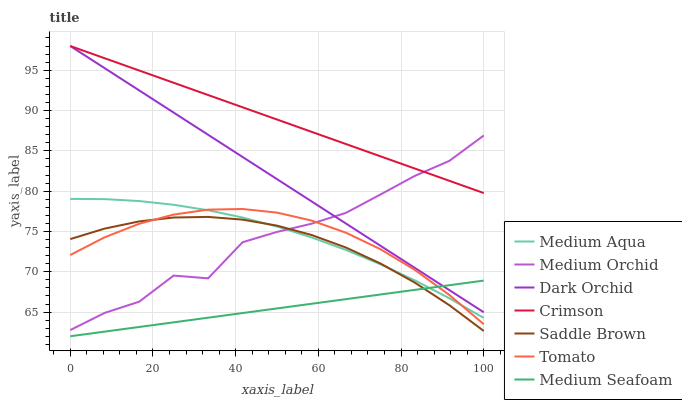Does Medium Seafoam have the minimum area under the curve?
Answer yes or no. Yes. Does Crimson have the maximum area under the curve?
Answer yes or no. Yes. Does Medium Orchid have the minimum area under the curve?
Answer yes or no. No. Does Medium Orchid have the maximum area under the curve?
Answer yes or no. No. Is Medium Seafoam the smoothest?
Answer yes or no. Yes. Is Medium Orchid the roughest?
Answer yes or no. Yes. Is Dark Orchid the smoothest?
Answer yes or no. No. Is Dark Orchid the roughest?
Answer yes or no. No. Does Medium Seafoam have the lowest value?
Answer yes or no. Yes. Does Medium Orchid have the lowest value?
Answer yes or no. No. Does Crimson have the highest value?
Answer yes or no. Yes. Does Medium Orchid have the highest value?
Answer yes or no. No. Is Medium Aqua less than Crimson?
Answer yes or no. Yes. Is Crimson greater than Tomato?
Answer yes or no. Yes. Does Tomato intersect Medium Aqua?
Answer yes or no. Yes. Is Tomato less than Medium Aqua?
Answer yes or no. No. Is Tomato greater than Medium Aqua?
Answer yes or no. No. Does Medium Aqua intersect Crimson?
Answer yes or no. No. 